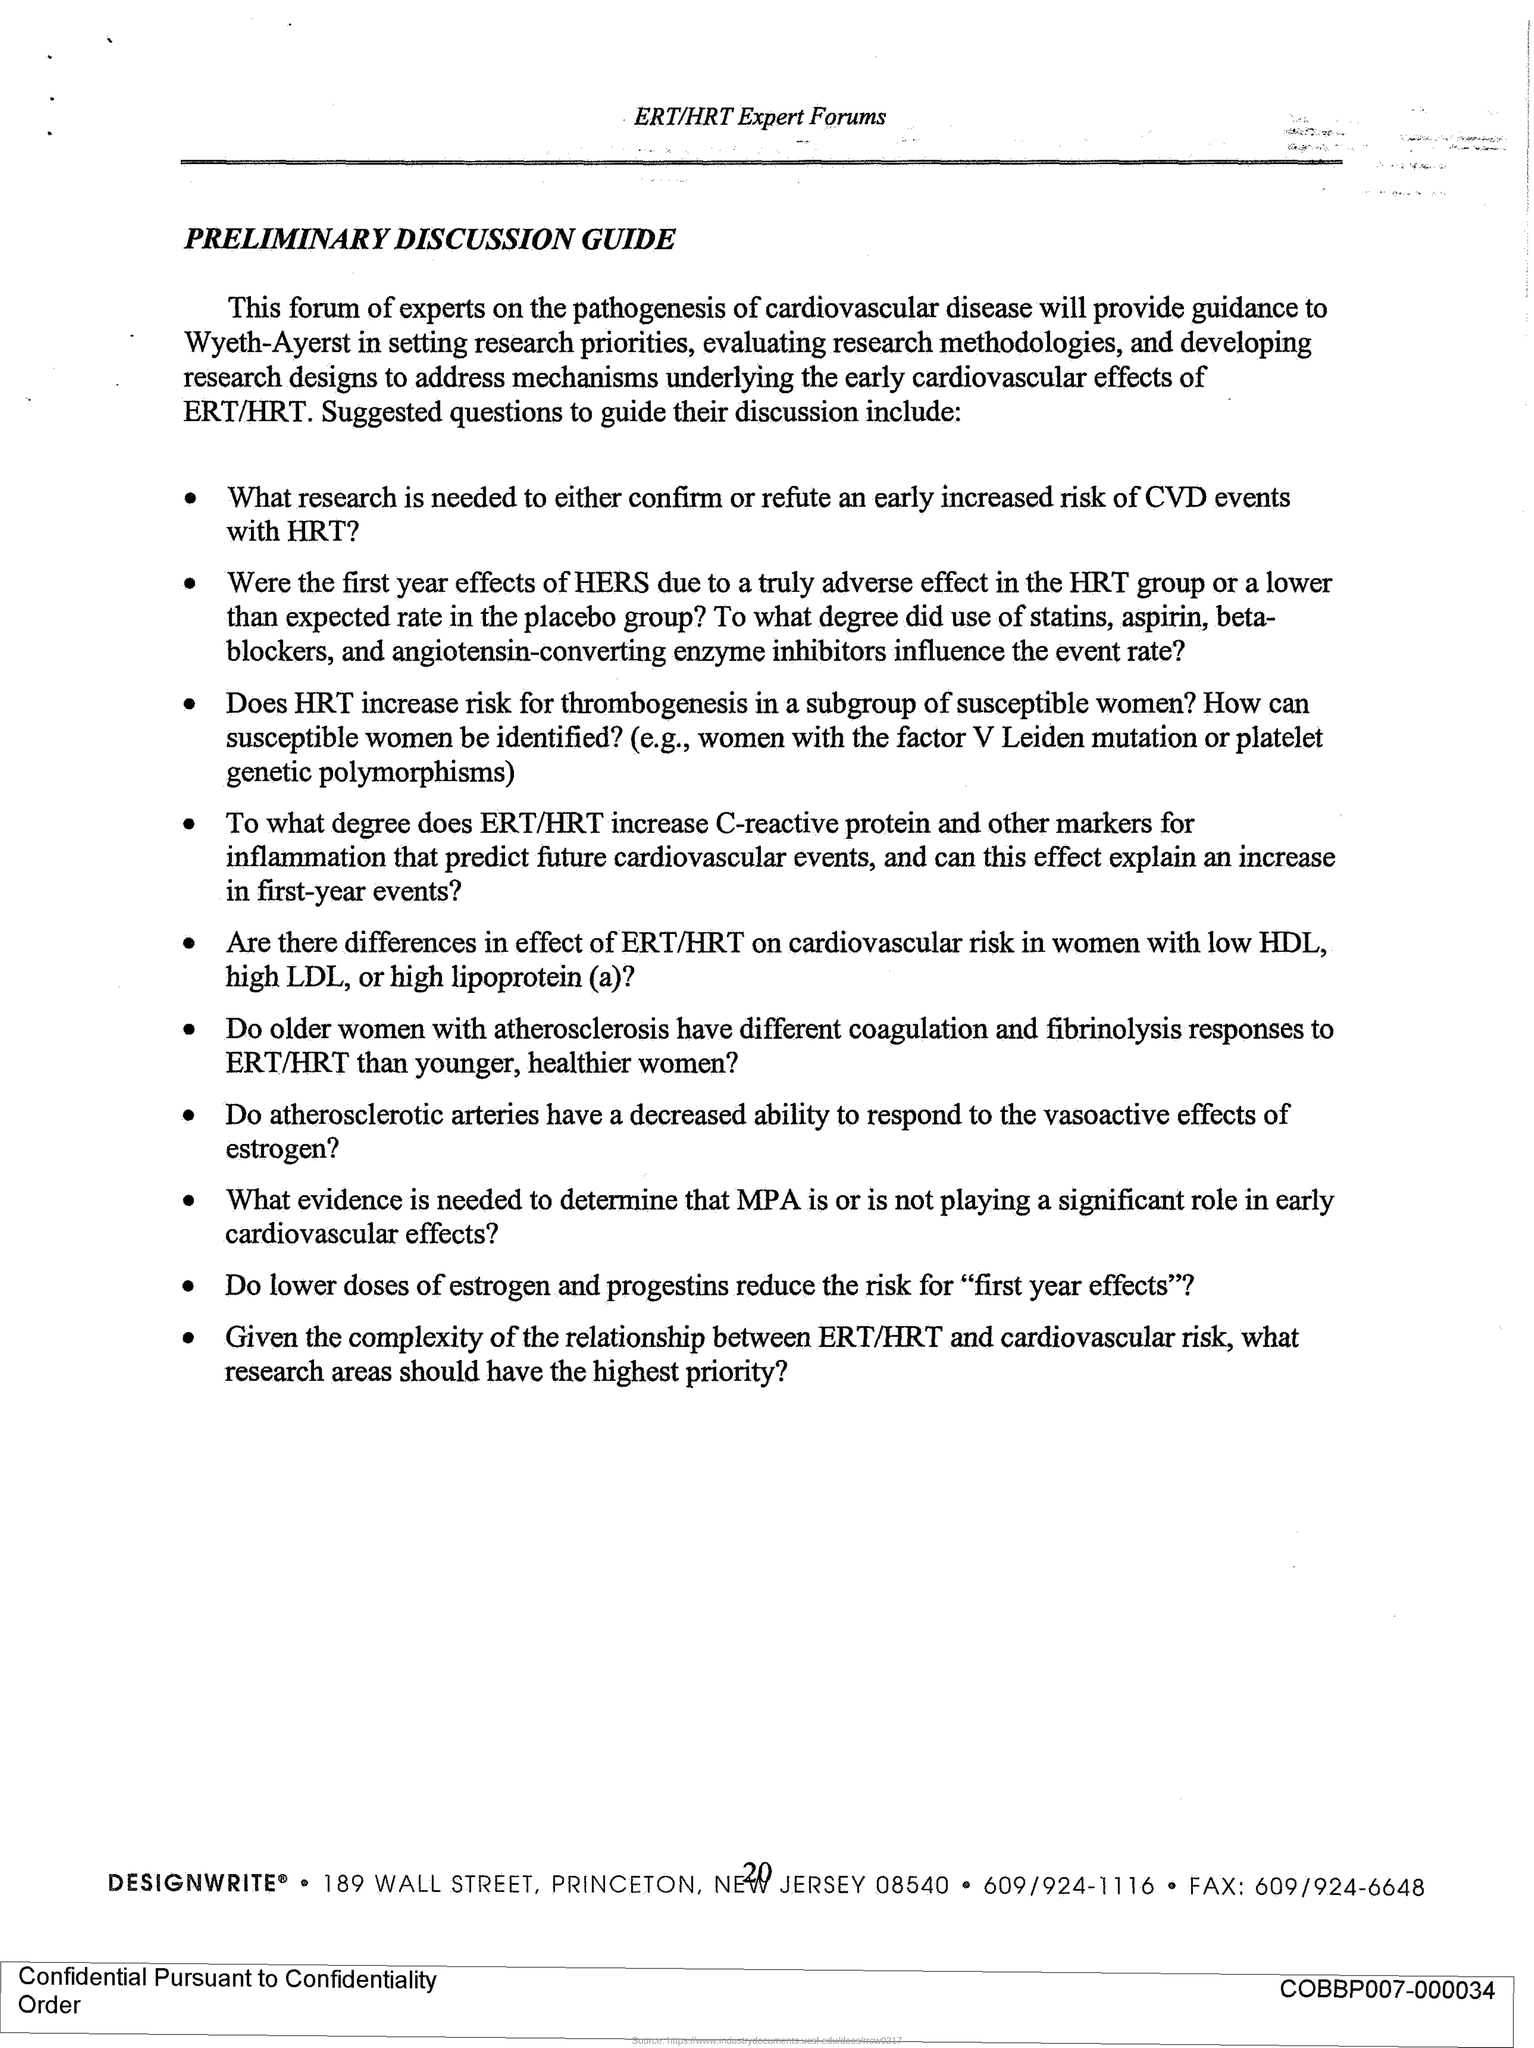What is the title of the document?
Keep it short and to the point. PRELIMINARY DISCUSSION GUIDE. What is the page number?
Keep it short and to the point. 20. What is the fax number?
Your response must be concise. 609/924-6648. 